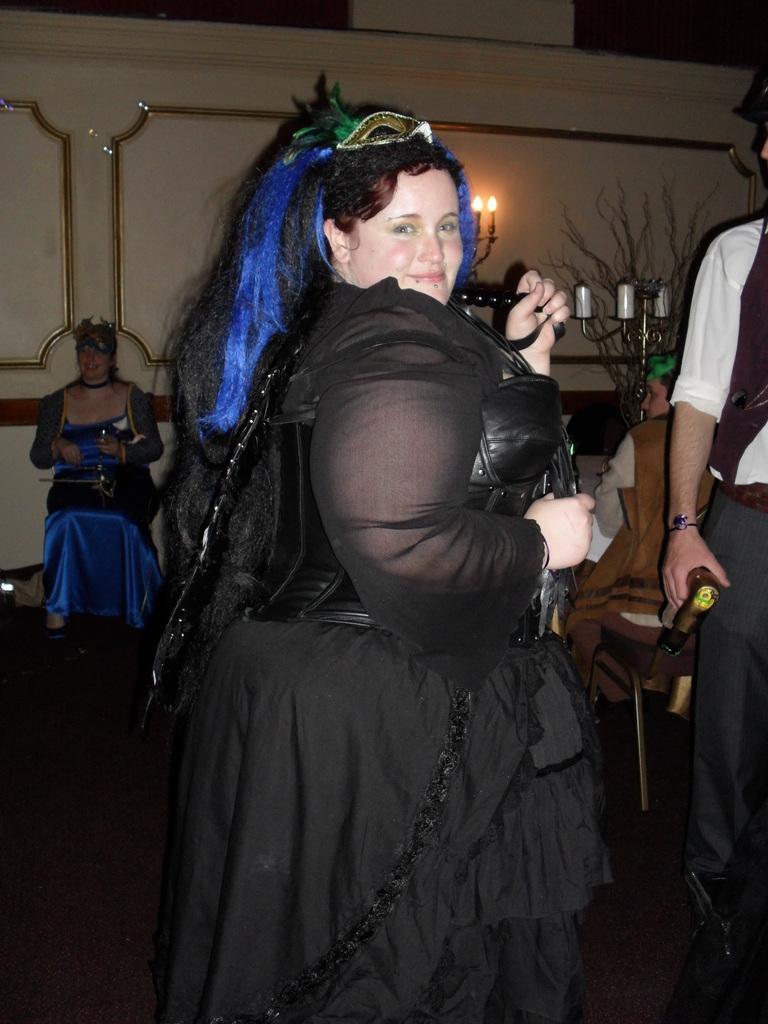Can you describe this image briefly? This image consists of a woman wearing black dress. She is dancing. To the right, there is a man standing. In the background, there is a wall along with the lights. At the bottom, there is a floor. 